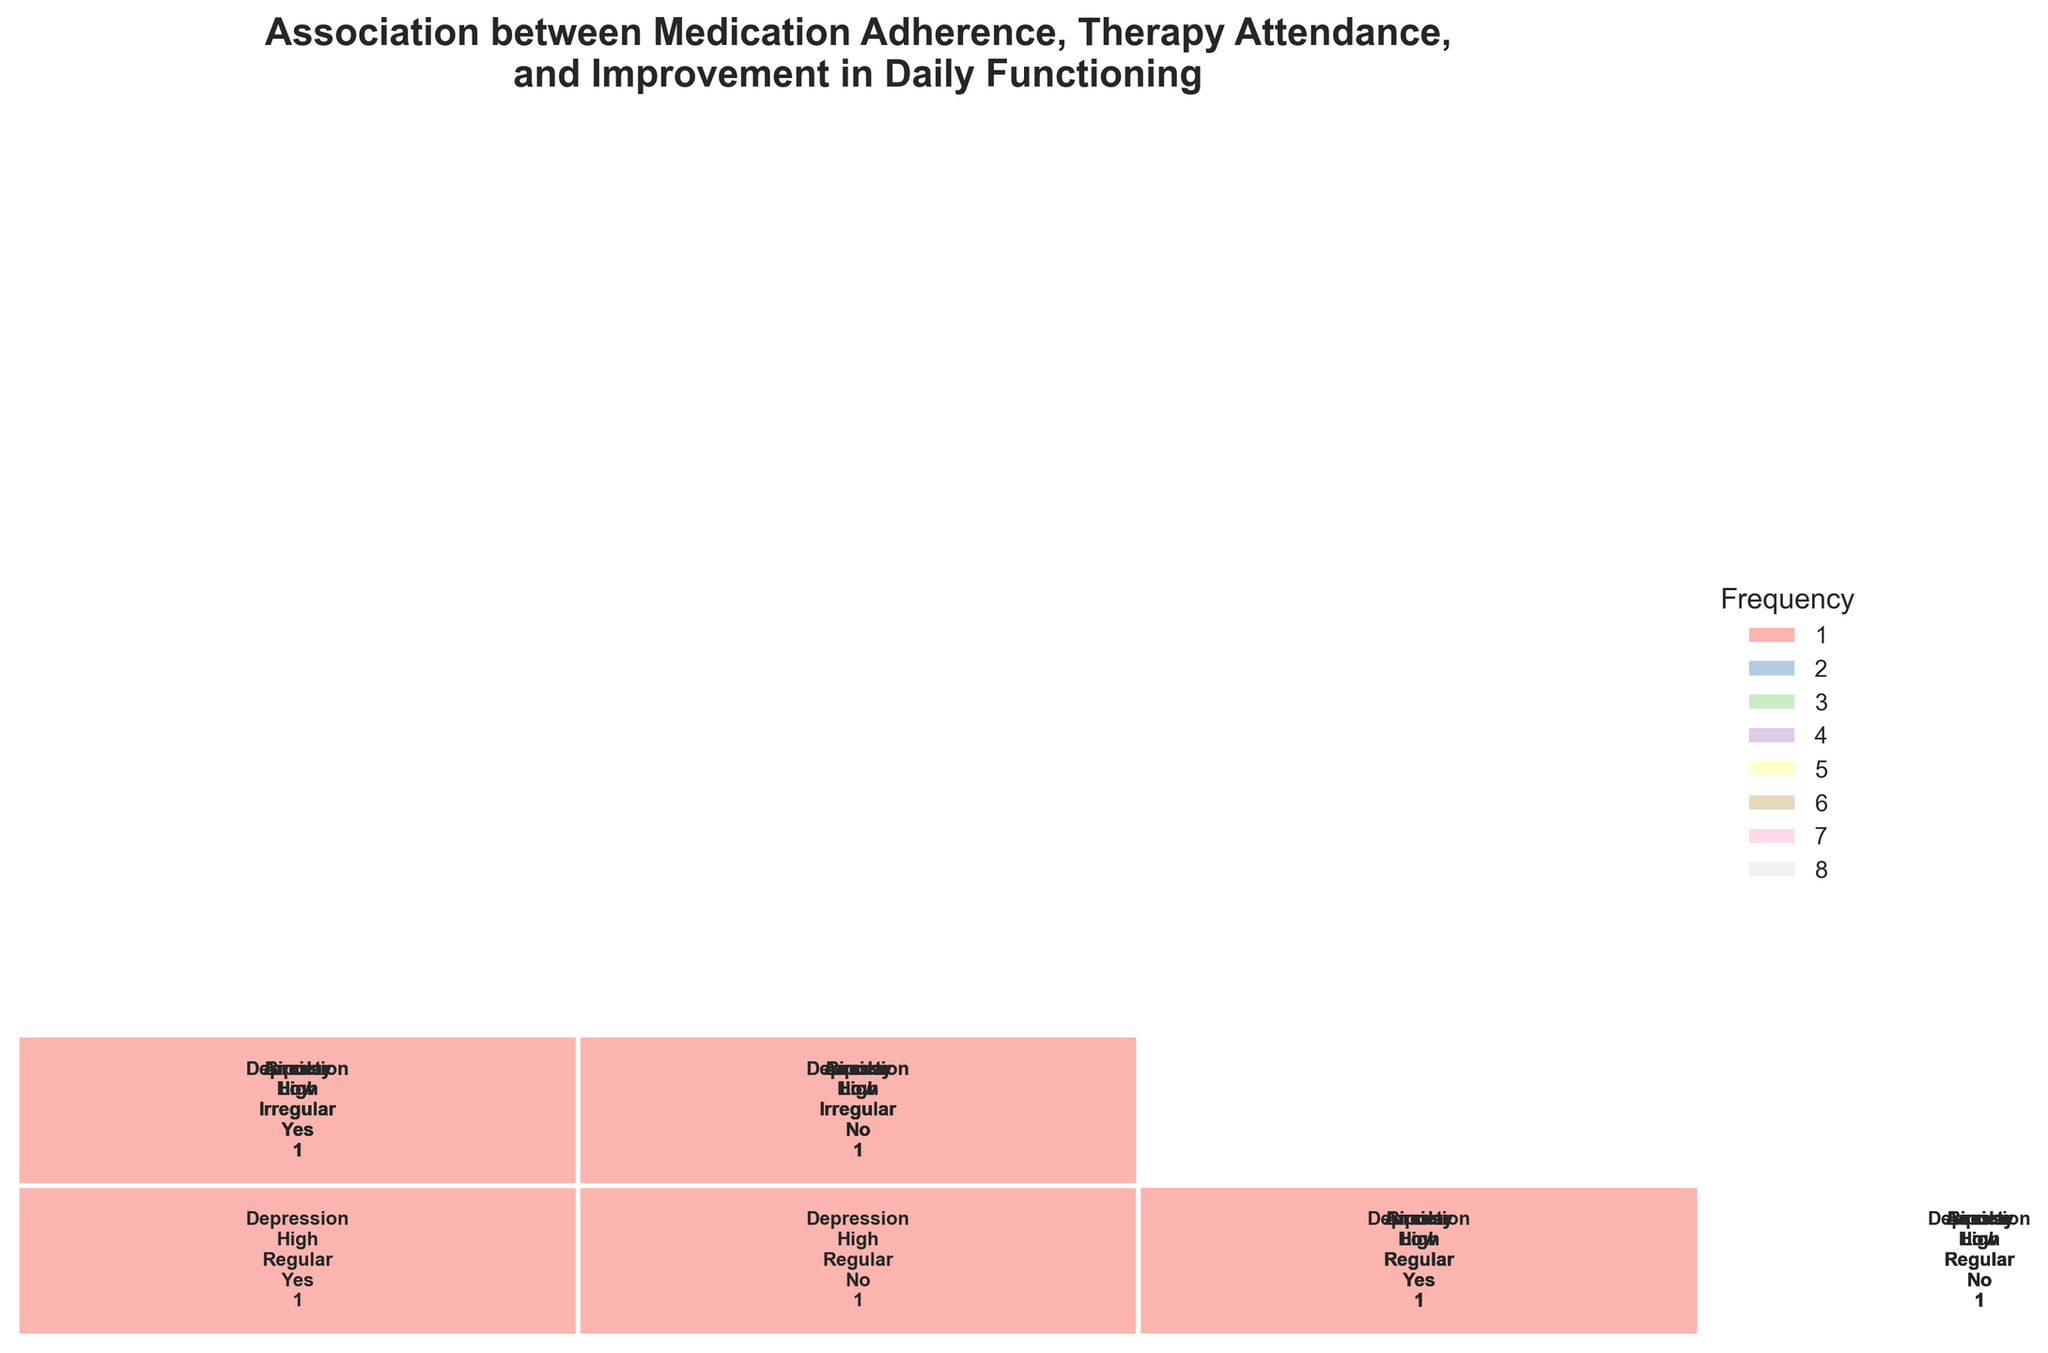What is the main title of the figure? The main title is usually found at the top of the figure and summarizes the focus of the figure. The title helps viewers understand the overall subject being depicted.
Answer: Association between Medication Adherence, Therapy Attendance, and Improvement in Daily Functioning What frequency value is indicated for 'High' medication adherence, 'Regular' therapy attendance, and 'Improved' functioning in patients with Depression? Locate the patch in the corresponding section of the mosaic plot for 'Depression' diagnosis, with 'High' medication adherence, 'Regular' therapy attendance, and 'Yes' for improvement. Check the frequency indicated within or near the patch.
Answer: 1 Which diagnosis category appears more frequently in the dataset based on the mosaic plot? By comparing the sizes of the mosaic sections (representing different diagnoses), the larger sections indicate a higher frequency of that diagnosis in the dataset.
Answer: Depression Is there a noticeable difference in improved daily functioning between 'High' and 'Low' medication adherence across the various diagnoses? Identify and compare the sections corresponding to 'High' and 'Low' medication adherence within each diagnosis. Look at the frequency values labeled as 'Yes' for improved functioning.
Answer: Yes Which diagnosis with 'Low' medication adherence and 'Irregular' therapy attendance shows no improvement in daily functioning? Locate the patches in the mosaic for each diagnosis associated with 'Low' medication adherence, 'Irregular' therapy attendance, and 'No' for improved functioning. Identify the diagnosis labels.
Answer: Depression, Anxiety, Bipolar How many different categories of therapy attendance are represented in the mosaic plot? Count the number of unique labels in the therapy attendance factor divides in the mosaic plot. Categories are usually distinguished visually or through labels.
Answer: 2 Are patients with Bipolar disorder more likely to show improved functioning with 'High' medication adherence? Focus on the sections of the mosaic plot with 'Bipolar' diagnosis and 'High' medication adherence. Compare the frequency values of 'Yes' and 'No' for improved functioning.
Answer: No What is the color used to represent the highest frequency value in the mosaic plot? Identify the color in the legend associated with the highest number label representing the highest frequency value.
Answer: Light Blue When therapy attendance is 'Regular', which diagnosis in combination with 'Low' medication adherence and improved functioning has the lowest frequency? Find the sections in the mosaic plot for 'Low' medication adherence, 'Regular' therapy attendance, and 'Yes' for improved functioning. Compare frequency values across diagnoses to find the lowest.
Answer: Depression 